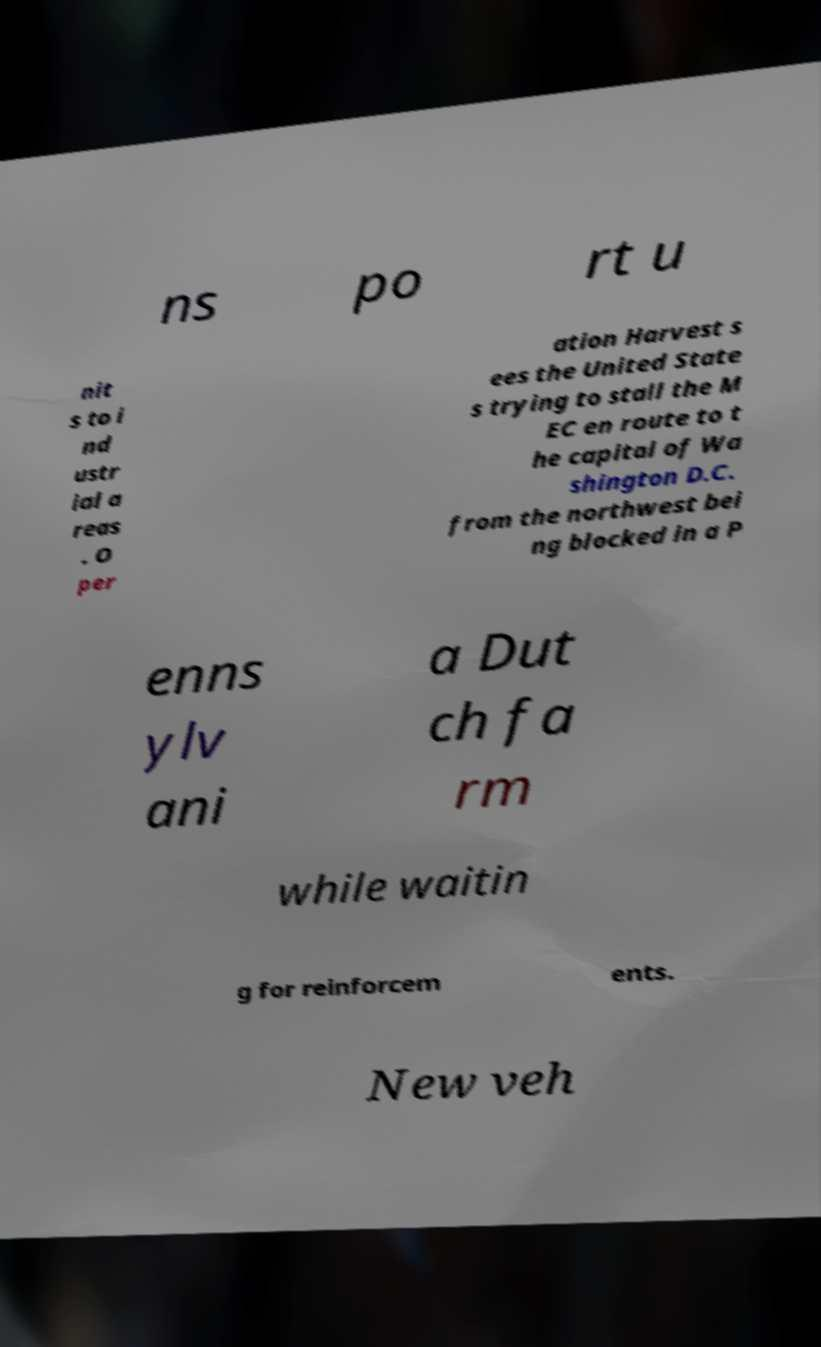Could you assist in decoding the text presented in this image and type it out clearly? ns po rt u nit s to i nd ustr ial a reas . O per ation Harvest s ees the United State s trying to stall the M EC en route to t he capital of Wa shington D.C. from the northwest bei ng blocked in a P enns ylv ani a Dut ch fa rm while waitin g for reinforcem ents. New veh 